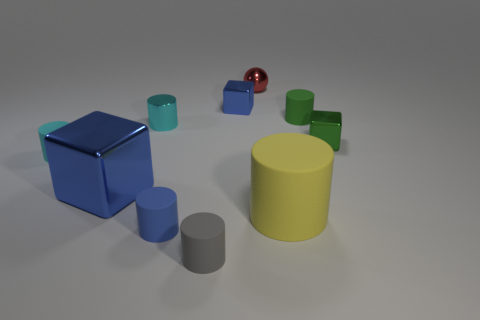Is the number of yellow cylinders less than the number of big brown metallic blocks?
Your answer should be very brief. No. What is the size of the shiny block that is on the left side of the green block and in front of the cyan metallic cylinder?
Offer a very short reply. Large. How big is the metallic block that is behind the small metallic block right of the tiny rubber object that is to the right of the ball?
Keep it short and to the point. Small. How many other things are there of the same color as the large matte object?
Provide a short and direct response. 0. There is a large object to the left of the yellow thing; is its color the same as the small shiny ball?
Offer a terse response. No. How many objects are yellow objects or large brown objects?
Your answer should be compact. 1. There is a big object to the left of the gray thing; what color is it?
Offer a very short reply. Blue. Are there fewer tiny things that are to the right of the tiny blue matte cylinder than green cubes?
Your answer should be compact. No. What is the size of the rubber thing that is the same color as the metal cylinder?
Offer a very short reply. Small. Is there any other thing that has the same size as the red shiny ball?
Keep it short and to the point. Yes. 